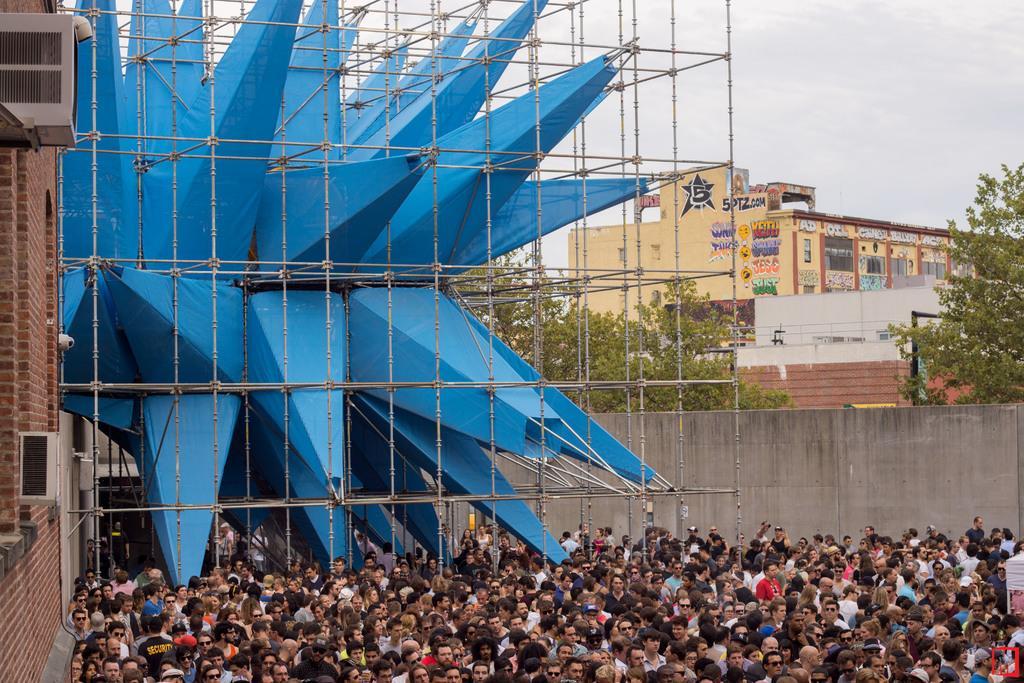How would you summarize this image in a sentence or two? In the foreground of this image, on the bottom, there is the crowd. On the left, there is a wall of a building and few air conditioners to it. In the middle, there is a blue structure and poles arranged in a cubical model around it. In the background, there are buildings, trees, sky and the cloud. 